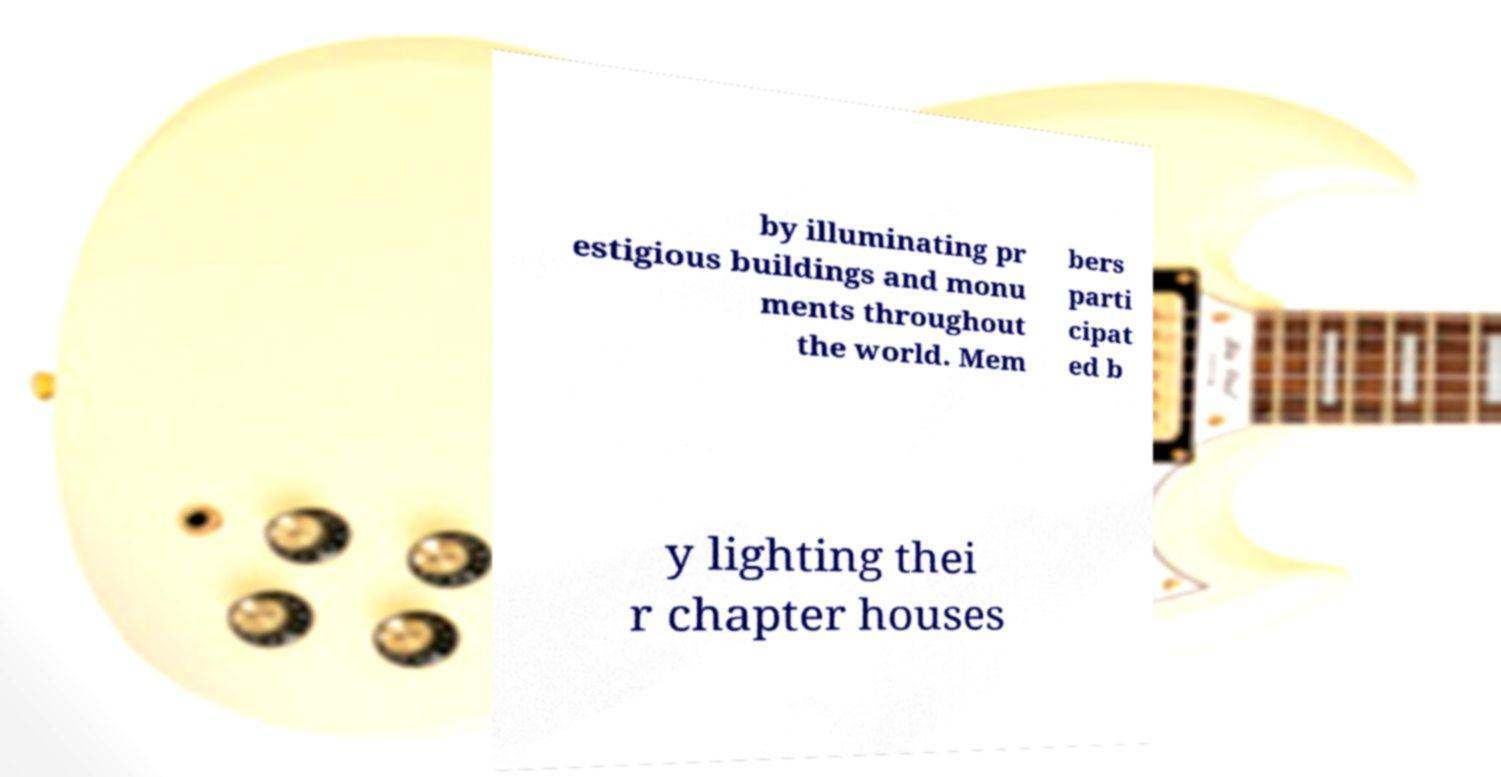Please read and relay the text visible in this image. What does it say? by illuminating pr estigious buildings and monu ments throughout the world. Mem bers parti cipat ed b y lighting thei r chapter houses 